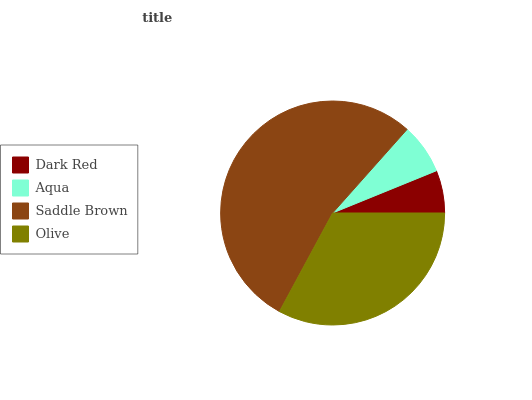Is Dark Red the minimum?
Answer yes or no. Yes. Is Saddle Brown the maximum?
Answer yes or no. Yes. Is Aqua the minimum?
Answer yes or no. No. Is Aqua the maximum?
Answer yes or no. No. Is Aqua greater than Dark Red?
Answer yes or no. Yes. Is Dark Red less than Aqua?
Answer yes or no. Yes. Is Dark Red greater than Aqua?
Answer yes or no. No. Is Aqua less than Dark Red?
Answer yes or no. No. Is Olive the high median?
Answer yes or no. Yes. Is Aqua the low median?
Answer yes or no. Yes. Is Saddle Brown the high median?
Answer yes or no. No. Is Olive the low median?
Answer yes or no. No. 